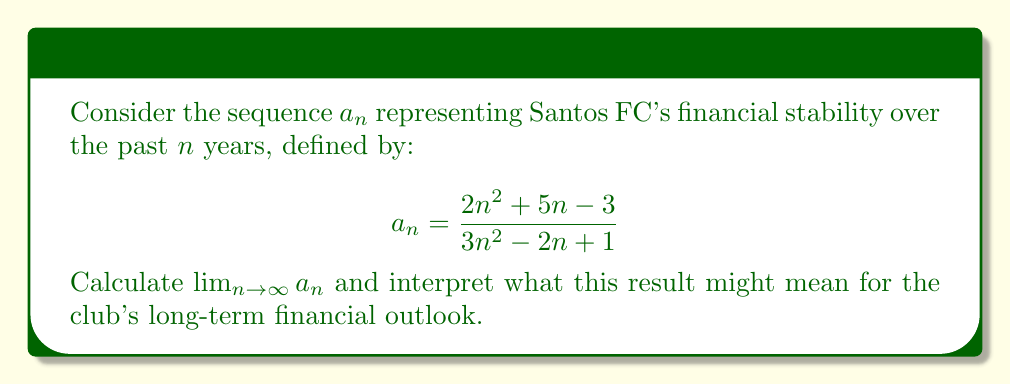Give your solution to this math problem. To find the limit of this sequence as $n$ approaches infinity, we can follow these steps:

1) First, let's examine the highest degree terms in both the numerator and denominator:

   Numerator: $2n^2$
   Denominator: $3n^2$

2) As $n$ approaches infinity, these highest degree terms will dominate. We can divide both the numerator and denominator by $n^2$:

   $$\lim_{n \to \infty} a_n = \lim_{n \to \infty} \frac{2n^2 + 5n - 3}{3n^2 - 2n + 1}$$
   $$= \lim_{n \to \infty} \frac{2 + \frac{5}{n} - \frac{3}{n^2}}{3 - \frac{2}{n} + \frac{1}{n^2}}$$

3) As $n$ approaches infinity, the terms $\frac{5}{n}$, $\frac{3}{n^2}$, $\frac{2}{n}$, and $\frac{1}{n^2}$ all approach 0.

4) Therefore, the limit simplifies to:

   $$\lim_{n \to \infty} a_n = \frac{2}{3}$$

5) Interpretation: This result suggests that Santos FC's financial stability is converging to a value of $\frac{2}{3}$ or approximately 0.667. In the context of financial stability, where 1 might represent perfect stability, this could indicate a long-term financial outlook that is stable but not optimal. It suggests room for improvement in the club's financial management.

For a skeptical fan, this result might reinforce concerns about the club's financial decisions. While the club isn't heading towards financial ruin (which would be indicated by a limit of 0 or a negative value), it's also not achieving the highest possible stability. This could be seen as a reflection of questionable financial strategies or missed opportunities for better financial management.
Answer: $\lim_{n \to \infty} a_n = \frac{2}{3}$ 